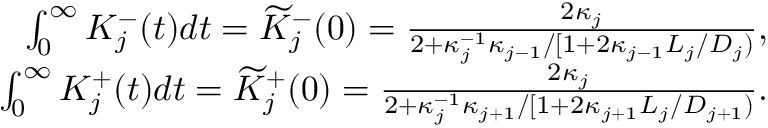<formula> <loc_0><loc_0><loc_500><loc_500>\begin{array} { r } { \int _ { 0 } ^ { \infty } K _ { j } ^ { - } ( t ) d t = \widetilde { K } _ { j } ^ { - } ( 0 ) = \frac { 2 \kappa _ { j } } { 2 + \kappa _ { j } ^ { - 1 } \kappa _ { j - 1 } / [ 1 + 2 \kappa _ { j - 1 } L _ { j } / D _ { j } ) } , } \\ { \int _ { 0 } ^ { \infty } K _ { j } ^ { + } ( t ) d t = \widetilde { K } _ { j } ^ { + } ( 0 ) = \frac { 2 \kappa _ { j } } { 2 + \kappa _ { j } ^ { - 1 } \kappa _ { j + 1 } / [ 1 + 2 \kappa _ { j + 1 } L _ { j } / D _ { j + 1 } ) } . } \end{array}</formula> 